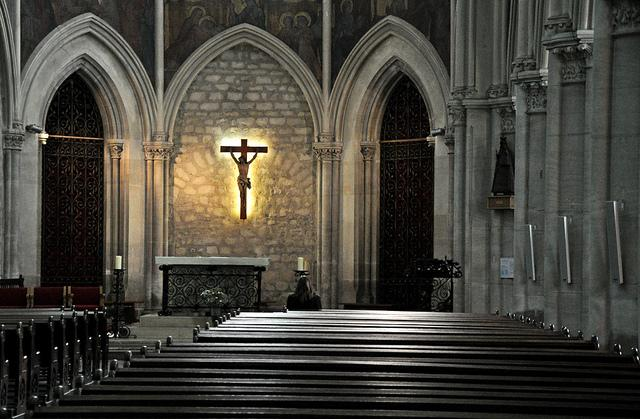How might you be considered if you set a fire here? Please explain your reasoning. sacrilegious. This is a church.  there is a cross on the wall. 